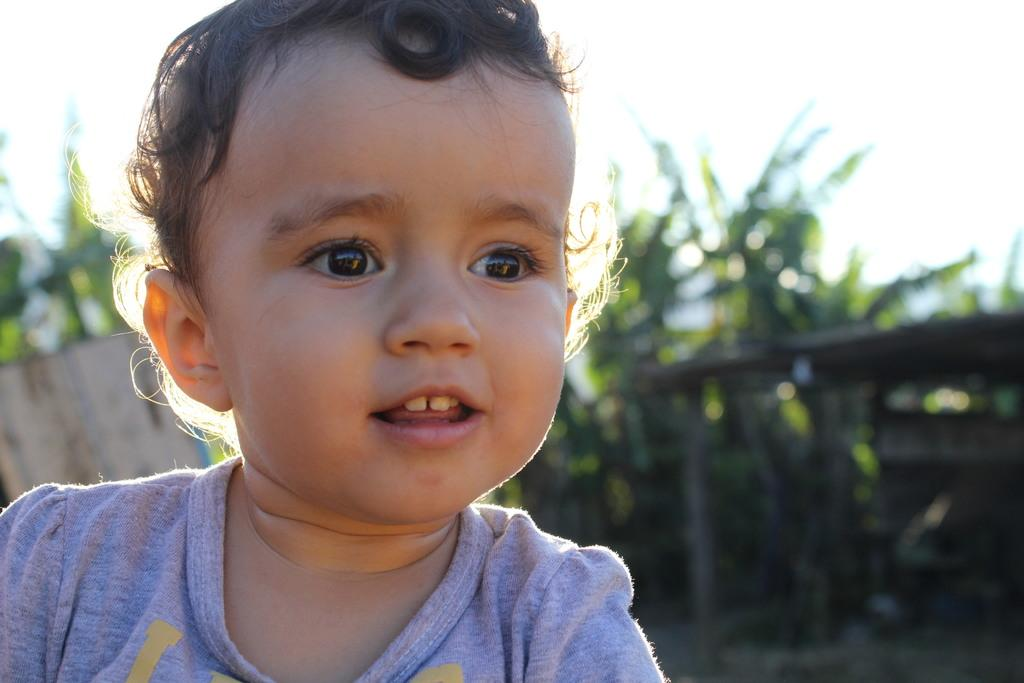What is located on the left side of the image? There is a baby on the left side of the image. What is the baby doing in the image? The baby is smiling in the image. What can be seen in the background of the image? There is a shed and trees in the background of the image. What is visible at the top of the image? The sky is visible at the top of the image. How many tomatoes are hanging from the shed in the image? There are no tomatoes visible in the image; only a shed and trees can be seen in the background. 